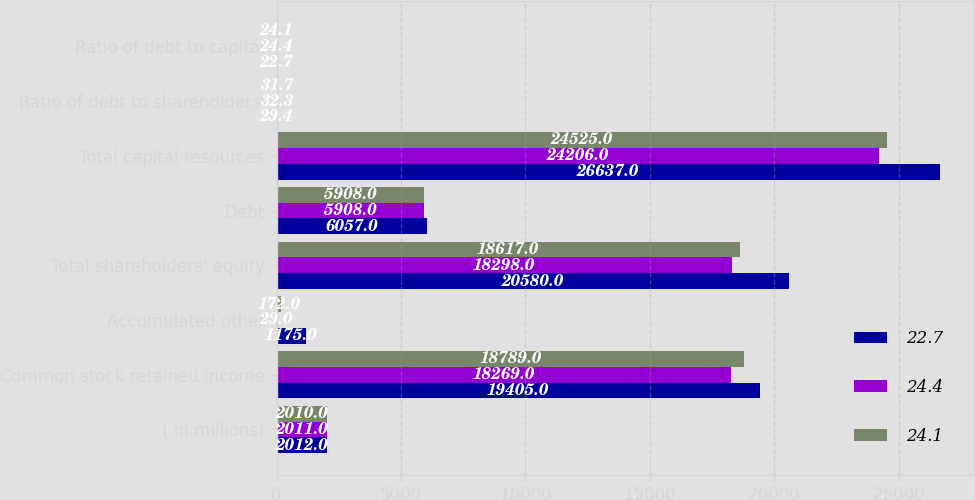<chart> <loc_0><loc_0><loc_500><loc_500><stacked_bar_chart><ecel><fcel>( in millions)<fcel>Common stock retained income<fcel>Accumulated other<fcel>Total shareholders' equity<fcel>Debt<fcel>Total capital resources<fcel>Ratio of debt to shareholders'<fcel>Ratio of debt to capital<nl><fcel>22.7<fcel>2012<fcel>19405<fcel>1175<fcel>20580<fcel>6057<fcel>26637<fcel>29.4<fcel>22.7<nl><fcel>24.4<fcel>2011<fcel>18269<fcel>29<fcel>18298<fcel>5908<fcel>24206<fcel>32.3<fcel>24.4<nl><fcel>24.1<fcel>2010<fcel>18789<fcel>172<fcel>18617<fcel>5908<fcel>24525<fcel>31.7<fcel>24.1<nl></chart> 